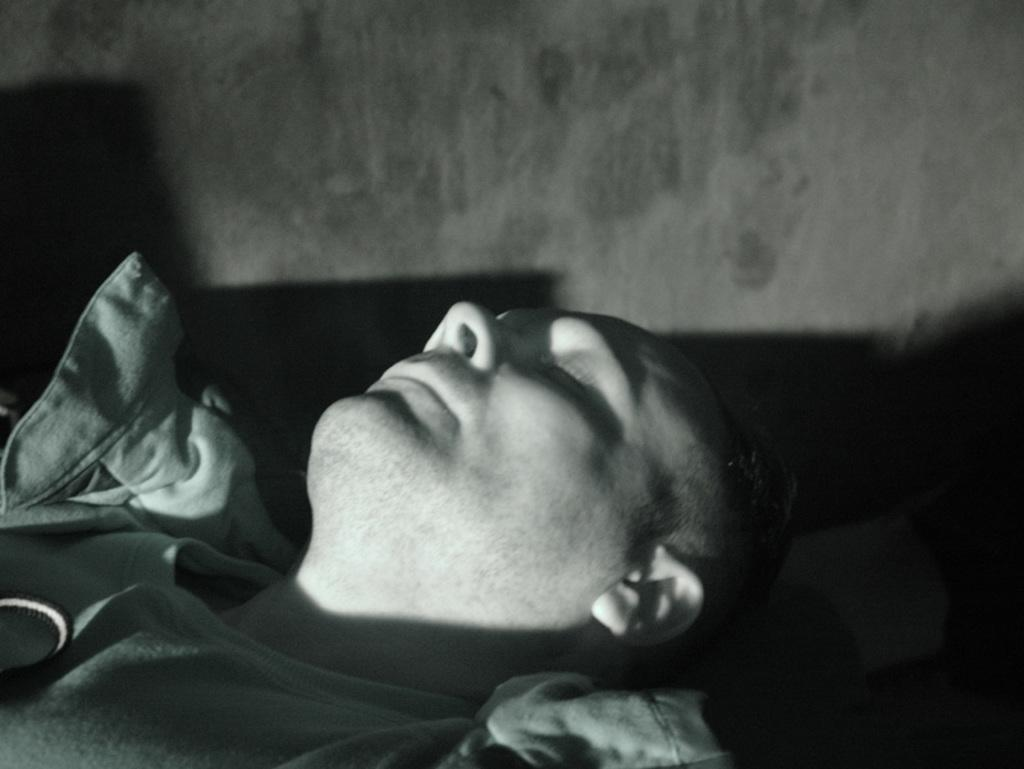Who is present in the image? There is a man in the image. What is the man doing in the image? The man is sleeping. What can be seen in the background of the image? There is a wall in the background of the image. What type of ice can be seen melting on the man's forehead in the image? There is no ice present in the image, and the man's forehead is not shown. 